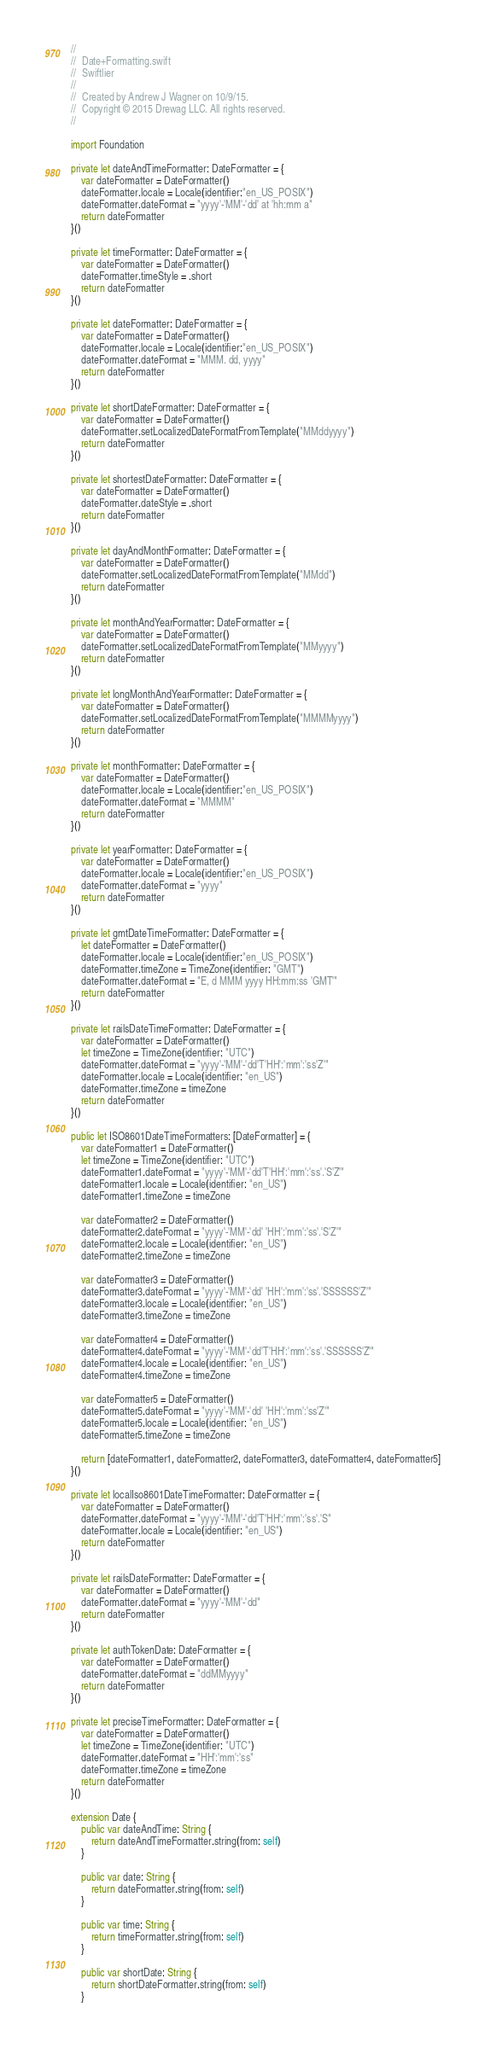<code> <loc_0><loc_0><loc_500><loc_500><_Swift_>//
//  Date+Formatting.swift
//  Swiftlier
//
//  Created by Andrew J Wagner on 10/9/15.
//  Copyright © 2015 Drewag LLC. All rights reserved.
//

import Foundation

private let dateAndTimeFormatter: DateFormatter = {
    var dateFormatter = DateFormatter()
    dateFormatter.locale = Locale(identifier:"en_US_POSIX")
    dateFormatter.dateFormat = "yyyy'-'MM'-'dd' at 'hh:mm a"
    return dateFormatter
}()

private let timeFormatter: DateFormatter = {
    var dateFormatter = DateFormatter()
    dateFormatter.timeStyle = .short
    return dateFormatter
}()

private let dateFormatter: DateFormatter = {
    var dateFormatter = DateFormatter()
    dateFormatter.locale = Locale(identifier:"en_US_POSIX")
    dateFormatter.dateFormat = "MMM. dd, yyyy"
    return dateFormatter
}()

private let shortDateFormatter: DateFormatter = {
    var dateFormatter = DateFormatter()
    dateFormatter.setLocalizedDateFormatFromTemplate("MMddyyyy")
    return dateFormatter
}()

private let shortestDateFormatter: DateFormatter = {
    var dateFormatter = DateFormatter()
    dateFormatter.dateStyle = .short
    return dateFormatter
}()

private let dayAndMonthFormatter: DateFormatter = {
    var dateFormatter = DateFormatter()
    dateFormatter.setLocalizedDateFormatFromTemplate("MMdd")
    return dateFormatter
}()

private let monthAndYearFormatter: DateFormatter = {
    var dateFormatter = DateFormatter()
    dateFormatter.setLocalizedDateFormatFromTemplate("MMyyyy")
    return dateFormatter
}()

private let longMonthAndYearFormatter: DateFormatter = {
    var dateFormatter = DateFormatter()
    dateFormatter.setLocalizedDateFormatFromTemplate("MMMMyyyy")
    return dateFormatter
}()

private let monthFormatter: DateFormatter = {
    var dateFormatter = DateFormatter()
    dateFormatter.locale = Locale(identifier:"en_US_POSIX")
    dateFormatter.dateFormat = "MMMM"
    return dateFormatter
}()

private let yearFormatter: DateFormatter = {
    var dateFormatter = DateFormatter()
    dateFormatter.locale = Locale(identifier:"en_US_POSIX")
    dateFormatter.dateFormat = "yyyy"
    return dateFormatter
}()

private let gmtDateTimeFormatter: DateFormatter = {
    let dateFormatter = DateFormatter()
    dateFormatter.locale = Locale(identifier:"en_US_POSIX")
    dateFormatter.timeZone = TimeZone(identifier: "GMT")
    dateFormatter.dateFormat = "E, d MMM yyyy HH:mm:ss 'GMT'"
    return dateFormatter
}()

private let railsDateTimeFormatter: DateFormatter = {
    var dateFormatter = DateFormatter()
    let timeZone = TimeZone(identifier: "UTC")
    dateFormatter.dateFormat = "yyyy'-'MM'-'dd'T'HH':'mm':'ss'Z'"
    dateFormatter.locale = Locale(identifier: "en_US")
    dateFormatter.timeZone = timeZone
    return dateFormatter
}()

public let ISO8601DateTimeFormatters: [DateFormatter] = {
    var dateFormatter1 = DateFormatter()
    let timeZone = TimeZone(identifier: "UTC")
    dateFormatter1.dateFormat = "yyyy'-'MM'-'dd'T'HH':'mm':'ss'.'S'Z'"
    dateFormatter1.locale = Locale(identifier: "en_US")
    dateFormatter1.timeZone = timeZone

    var dateFormatter2 = DateFormatter()
    dateFormatter2.dateFormat = "yyyy'-'MM'-'dd' 'HH':'mm':'ss'.'S'Z'"
    dateFormatter2.locale = Locale(identifier: "en_US")
    dateFormatter2.timeZone = timeZone

    var dateFormatter3 = DateFormatter()
    dateFormatter3.dateFormat = "yyyy'-'MM'-'dd' 'HH':'mm':'ss'.'SSSSSS'Z'"
    dateFormatter3.locale = Locale(identifier: "en_US")
    dateFormatter3.timeZone = timeZone

    var dateFormatter4 = DateFormatter()
    dateFormatter4.dateFormat = "yyyy'-'MM'-'dd'T'HH':'mm':'ss'.'SSSSSS'Z'"
    dateFormatter4.locale = Locale(identifier: "en_US")
    dateFormatter4.timeZone = timeZone

    var dateFormatter5 = DateFormatter()
    dateFormatter5.dateFormat = "yyyy'-'MM'-'dd' 'HH':'mm':'ss'Z'"
    dateFormatter5.locale = Locale(identifier: "en_US")
    dateFormatter5.timeZone = timeZone

    return [dateFormatter1, dateFormatter2, dateFormatter3, dateFormatter4, dateFormatter5]
}()

private let localIso8601DateTimeFormatter: DateFormatter = {
    var dateFormatter = DateFormatter()
    dateFormatter.dateFormat = "yyyy'-'MM'-'dd'T'HH':'mm':'ss'.'S"
    dateFormatter.locale = Locale(identifier: "en_US")
    return dateFormatter
}()

private let railsDateFormatter: DateFormatter = {
    var dateFormatter = DateFormatter()
    dateFormatter.dateFormat = "yyyy'-'MM'-'dd"
    return dateFormatter
}()

private let authTokenDate: DateFormatter = {
    var dateFormatter = DateFormatter()
    dateFormatter.dateFormat = "ddMMyyyy"
    return dateFormatter
}()

private let preciseTimeFormatter: DateFormatter = {
    var dateFormatter = DateFormatter()
    let timeZone = TimeZone(identifier: "UTC")
    dateFormatter.dateFormat = "HH':'mm':'ss"
    dateFormatter.timeZone = timeZone
    return dateFormatter
}()

extension Date {
    public var dateAndTime: String {
        return dateAndTimeFormatter.string(from: self)
    }

    public var date: String {
        return dateFormatter.string(from: self)
    }

    public var time: String {
        return timeFormatter.string(from: self)
    }

    public var shortDate: String {
        return shortDateFormatter.string(from: self)
    }
</code> 